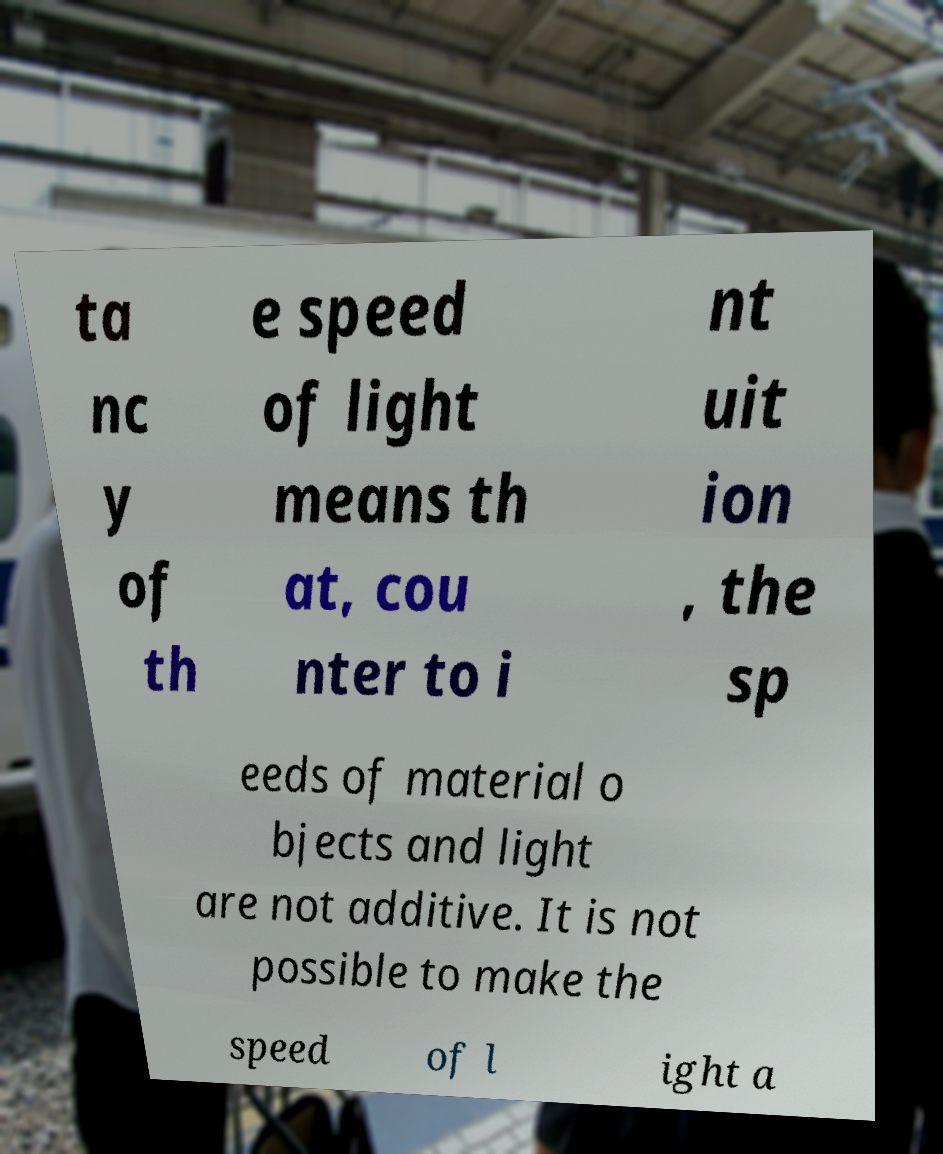Please read and relay the text visible in this image. What does it say? ta nc y of th e speed of light means th at, cou nter to i nt uit ion , the sp eeds of material o bjects and light are not additive. It is not possible to make the speed of l ight a 